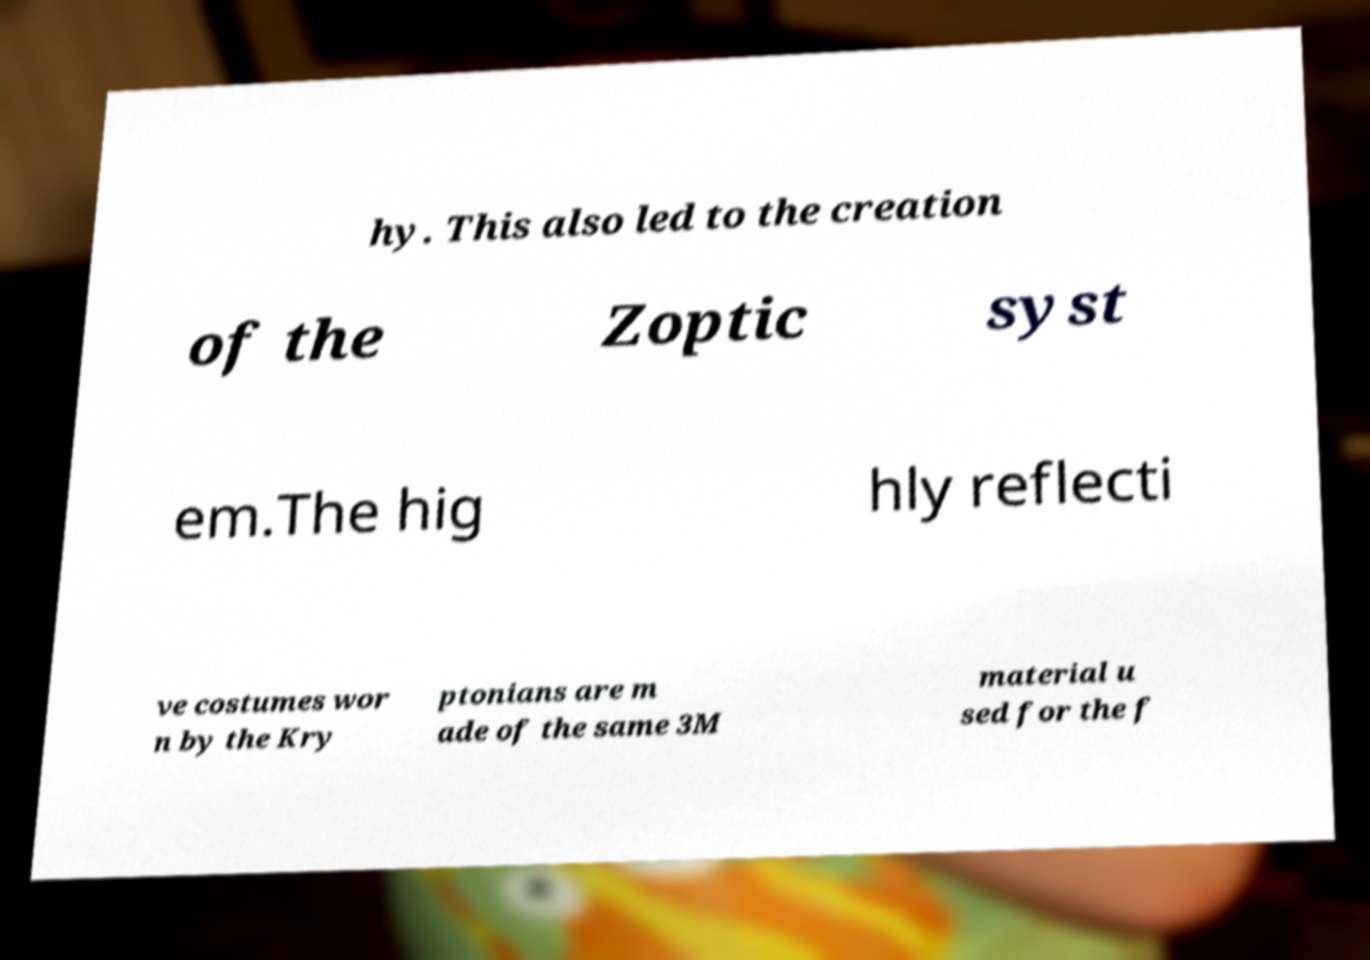Please identify and transcribe the text found in this image. hy. This also led to the creation of the Zoptic syst em.The hig hly reflecti ve costumes wor n by the Kry ptonians are m ade of the same 3M material u sed for the f 